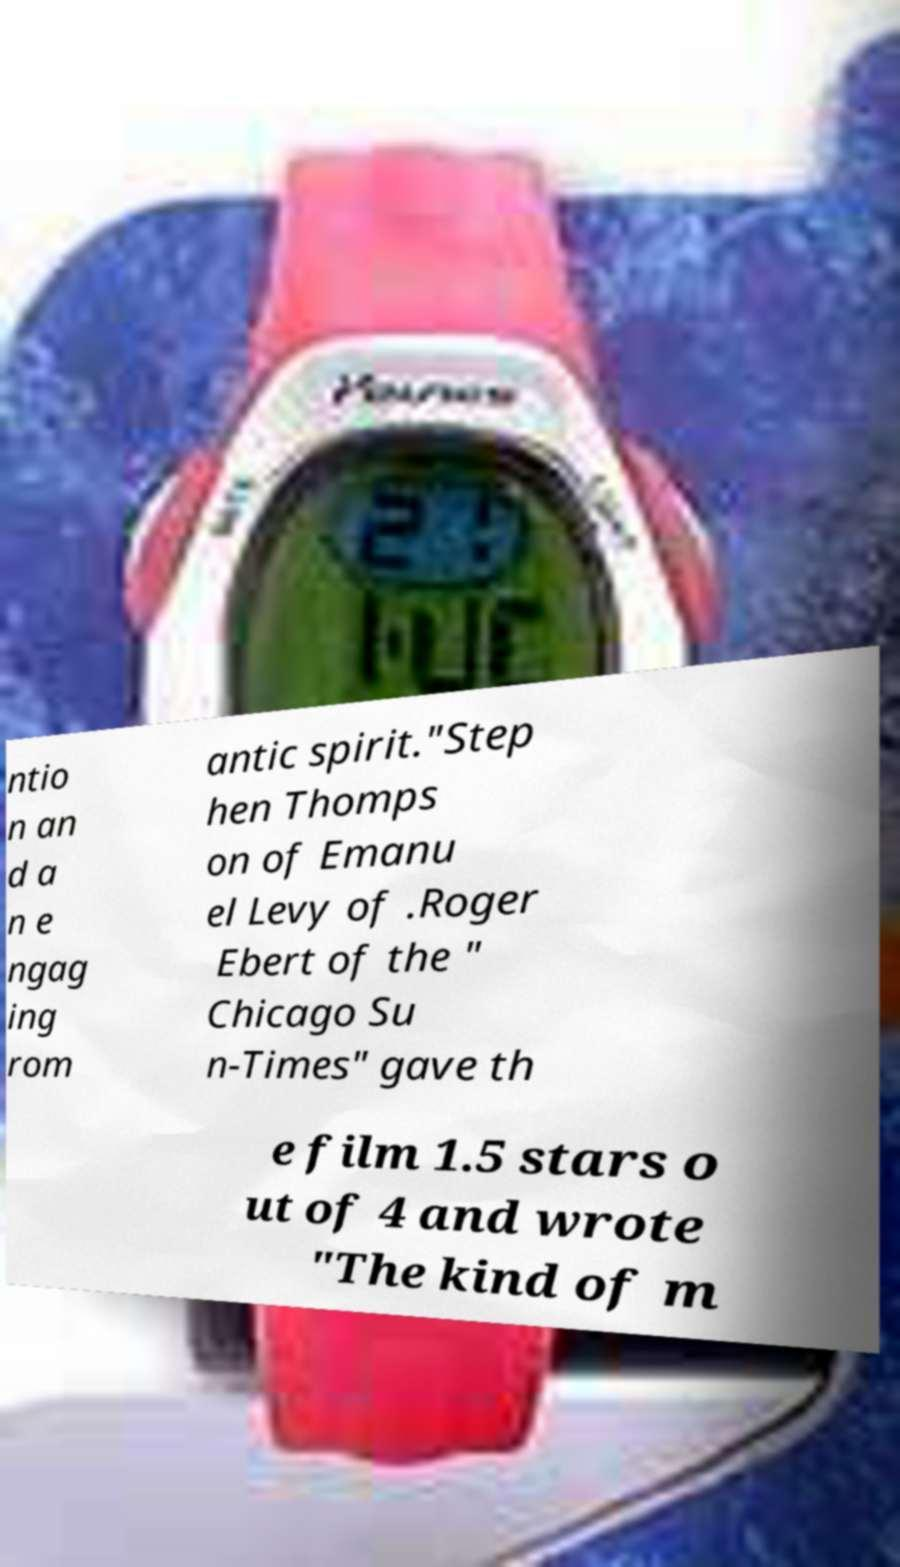There's text embedded in this image that I need extracted. Can you transcribe it verbatim? ntio n an d a n e ngag ing rom antic spirit."Step hen Thomps on of Emanu el Levy of .Roger Ebert of the " Chicago Su n-Times" gave th e film 1.5 stars o ut of 4 and wrote "The kind of m 